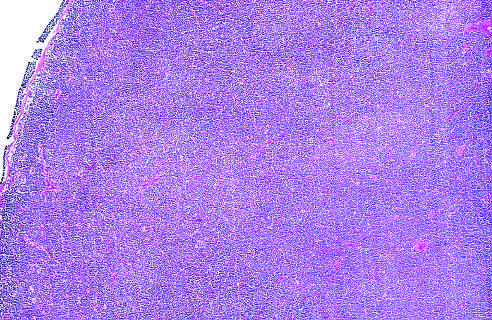what shows diffuse effacement of nodal architecture?
Answer the question using a single word or phrase. Low-power view 